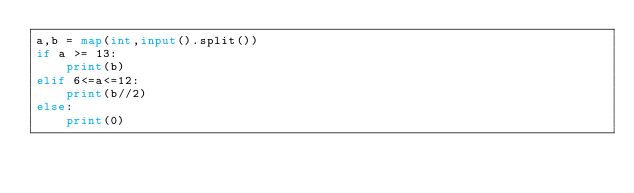<code> <loc_0><loc_0><loc_500><loc_500><_Python_>a,b = map(int,input().split())
if a >= 13:
    print(b)
elif 6<=a<=12:
    print(b//2)
else:
    print(0)</code> 